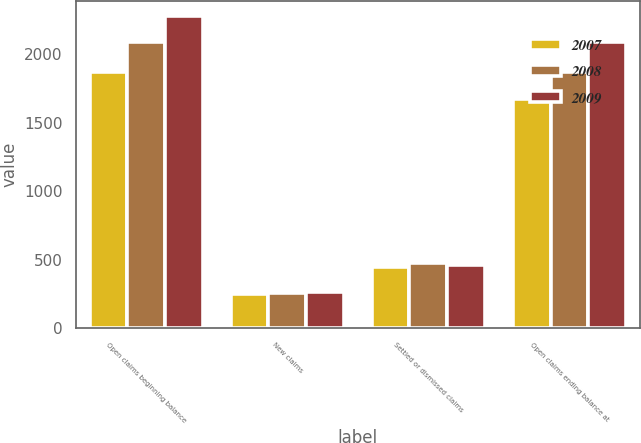<chart> <loc_0><loc_0><loc_500><loc_500><stacked_bar_chart><ecel><fcel>Open claims beginning balance<fcel>New claims<fcel>Settled or dismissed claims<fcel>Open claims ending balance at<nl><fcel>2007<fcel>1867<fcel>249<fcel>446<fcel>1670<nl><fcel>2008<fcel>2086<fcel>256<fcel>475<fcel>1867<nl><fcel>2009<fcel>2277<fcel>269<fcel>460<fcel>2086<nl></chart> 